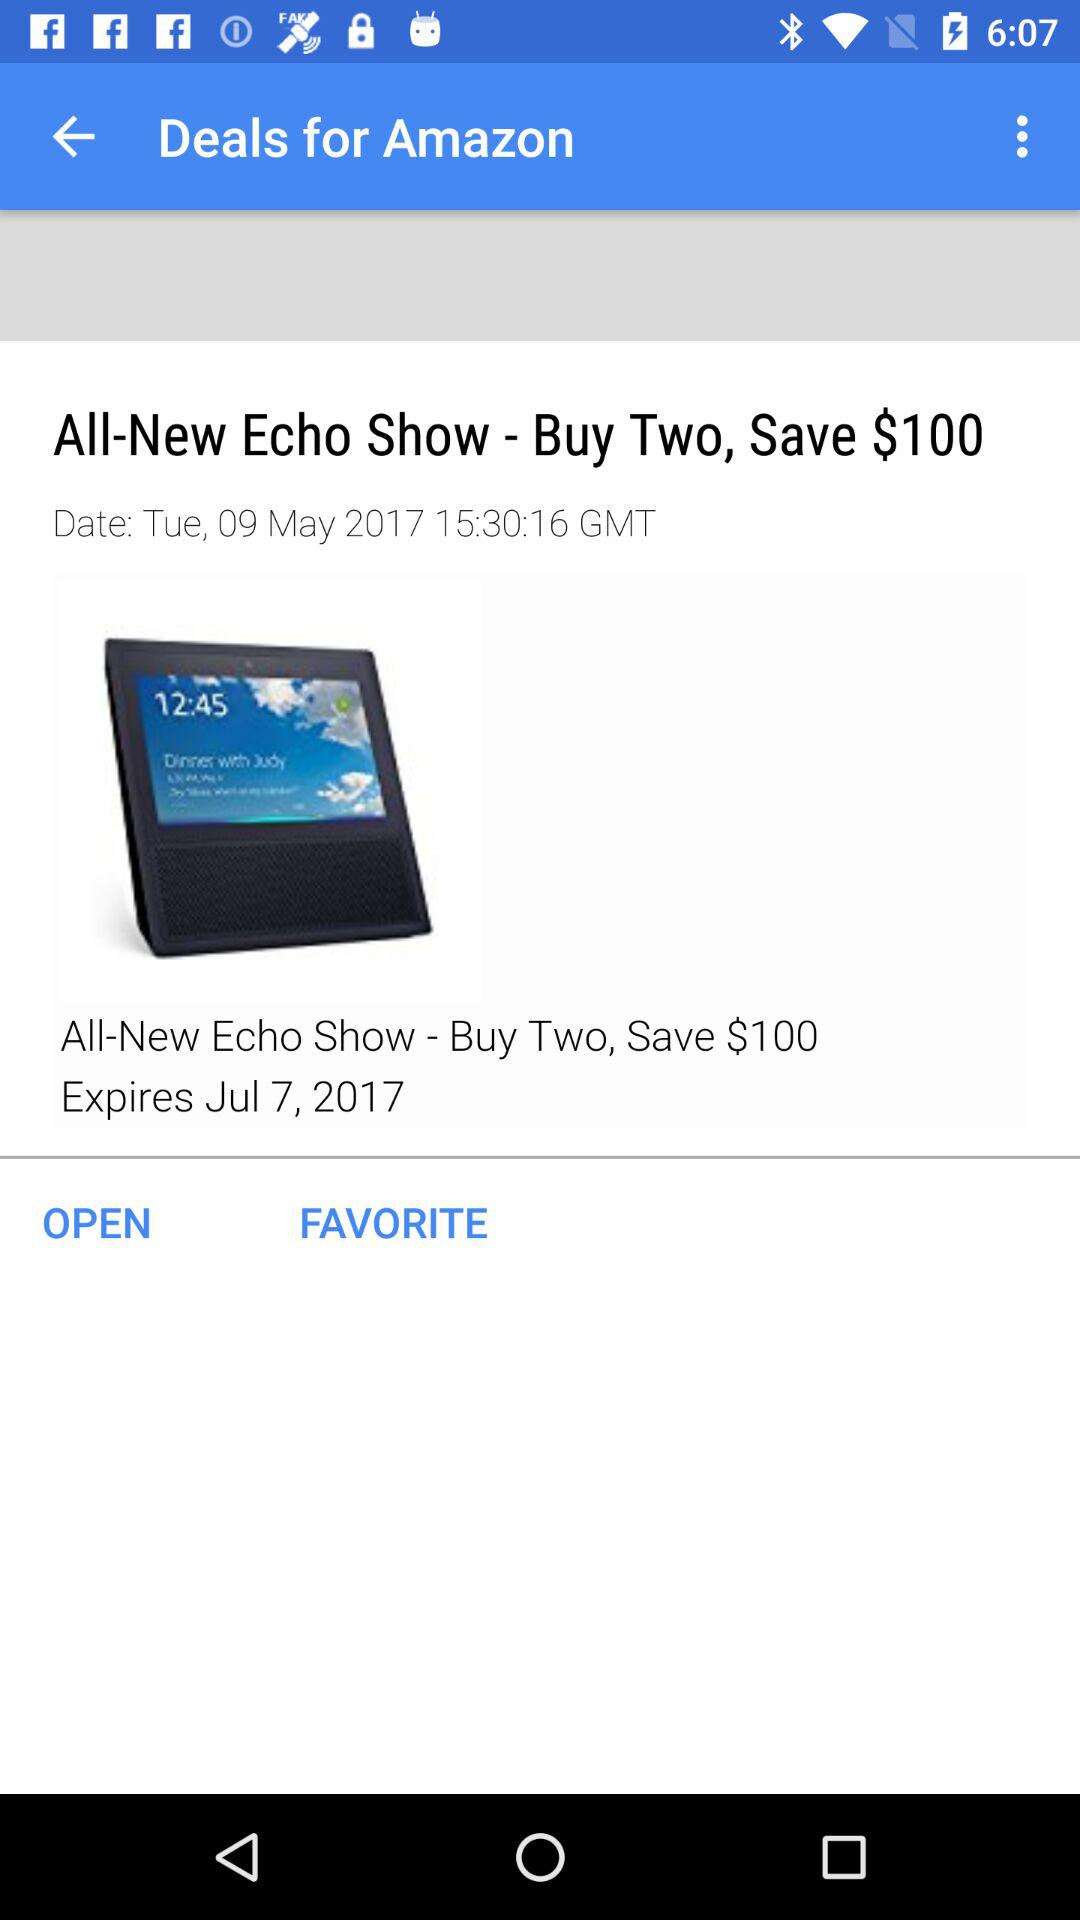How much can be saved by buying two "Echo Show"? The amount that can be saved by buying two "Echo Show" is $100. 